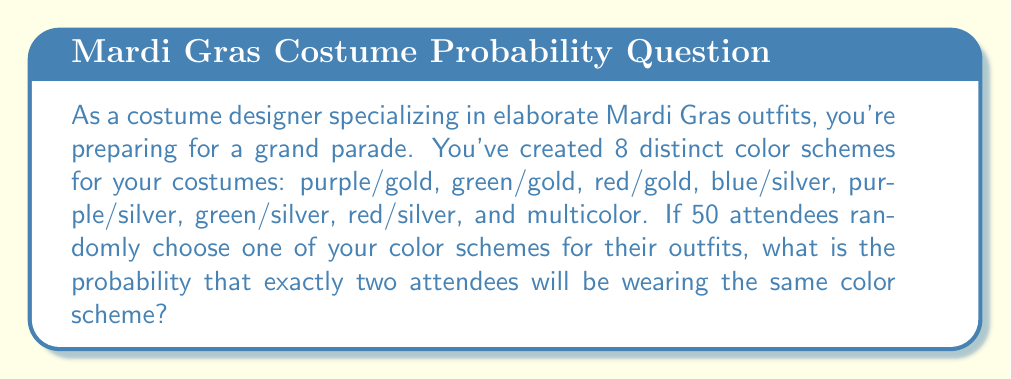Teach me how to tackle this problem. To solve this problem, we'll use the concept of probability and the binomial distribution.

1) First, let's calculate the probability of a single color scheme being chosen:
   $p = \frac{1}{8}$ (as there are 8 color schemes to choose from)

2) The probability of not choosing a specific color scheme is:
   $q = 1 - p = \frac{7}{8}$

3) We want exactly two attendees to wear the same color scheme. This can happen for any of the 8 color schemes. For each color scheme:
   - Exactly 2 out of 50 attendees should choose it
   - The other 48 should not choose it

4) This scenario follows a binomial distribution. The probability for one color scheme is:
   $$\binom{50}{2} \cdot p^2 \cdot q^{48}$$

   Where $\binom{50}{2}$ is the binomial coefficient, calculated as:
   $$\binom{50}{2} = \frac{50!}{2!(50-2)!} = \frac{50 \cdot 49}{2} = 1225$$

5) Since this can happen for any of the 8 color schemes, and we want it to happen for exactly one of them, we multiply by 8 and then by the probability that it doesn't happen for the other 7 schemes:

   $$8 \cdot \binom{50}{2} \cdot p^2 \cdot q^{48} \cdot (1 - \binom{50}{2} \cdot p^2 \cdot q^{48})^7$$

6) Let's calculate:
   $$8 \cdot 1225 \cdot (\frac{1}{8})^2 \cdot (\frac{7}{8})^{48} \cdot (1 - 1225 \cdot (\frac{1}{8})^2 \cdot (\frac{7}{8})^{48})^7$$

7) Using a calculator for the final computation:
   $$\approx 0.1839 \text{ or about } 18.39\%$$
Answer: The probability that exactly two attendees will be wearing the same color scheme is approximately 0.1839 or 18.39%. 